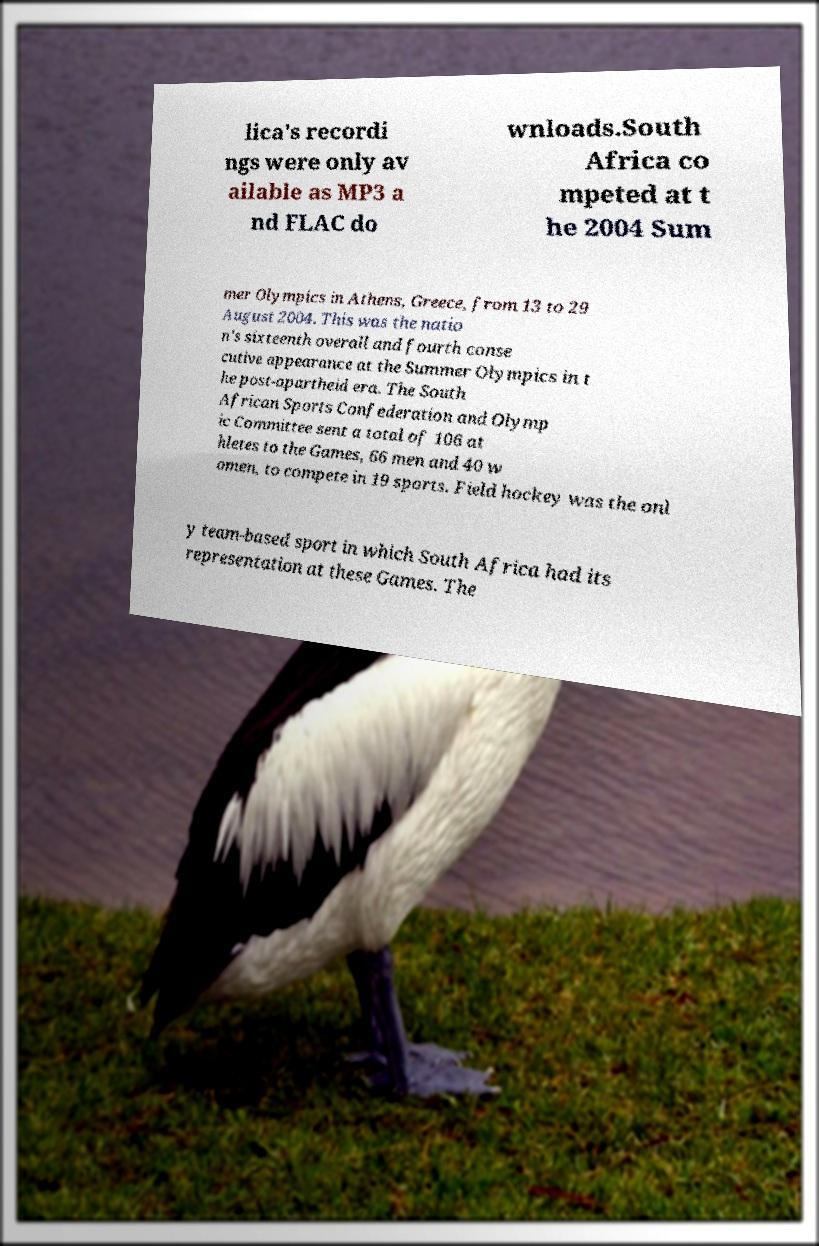Can you accurately transcribe the text from the provided image for me? lica's recordi ngs were only av ailable as MP3 a nd FLAC do wnloads.South Africa co mpeted at t he 2004 Sum mer Olympics in Athens, Greece, from 13 to 29 August 2004. This was the natio n's sixteenth overall and fourth conse cutive appearance at the Summer Olympics in t he post-apartheid era. The South African Sports Confederation and Olymp ic Committee sent a total of 106 at hletes to the Games, 66 men and 40 w omen, to compete in 19 sports. Field hockey was the onl y team-based sport in which South Africa had its representation at these Games. The 